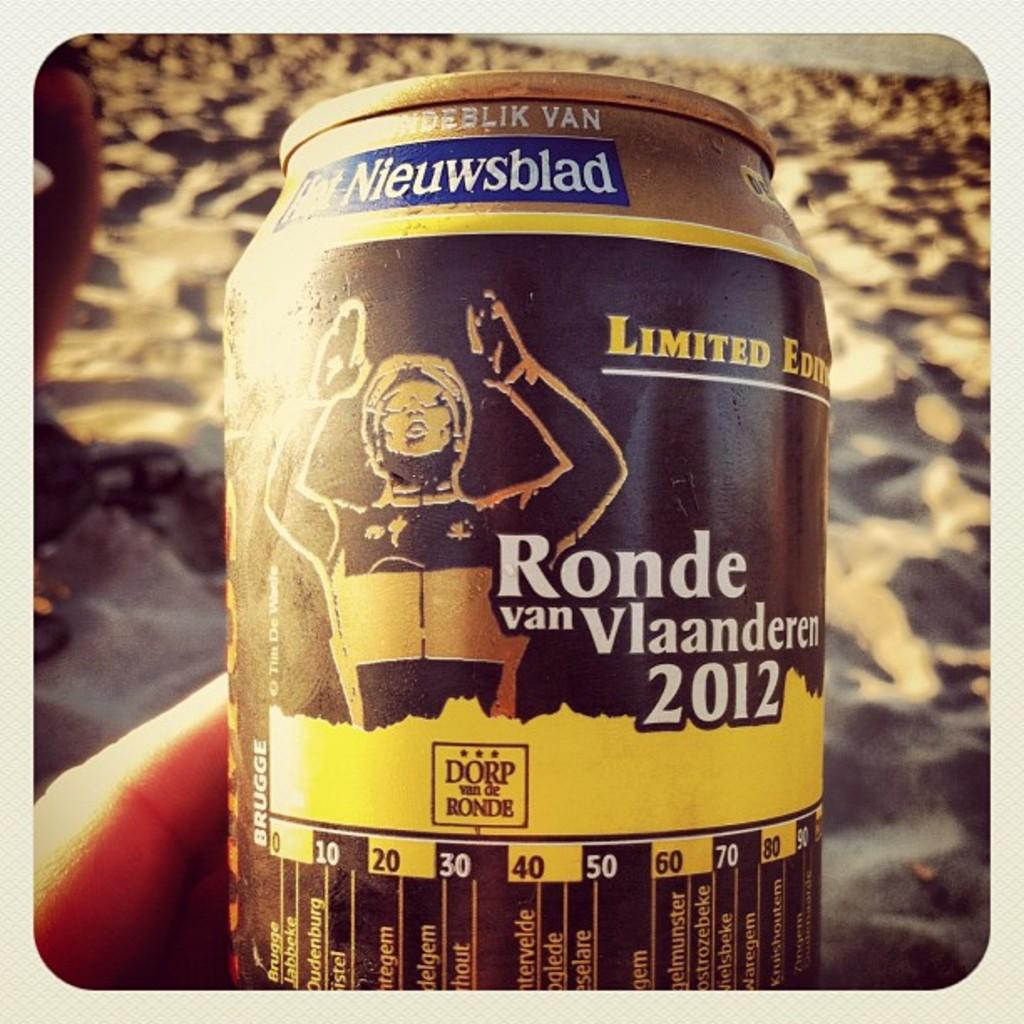<image>
Give a short and clear explanation of the subsequent image. A can shows Ronde van Vlaanderen on it 